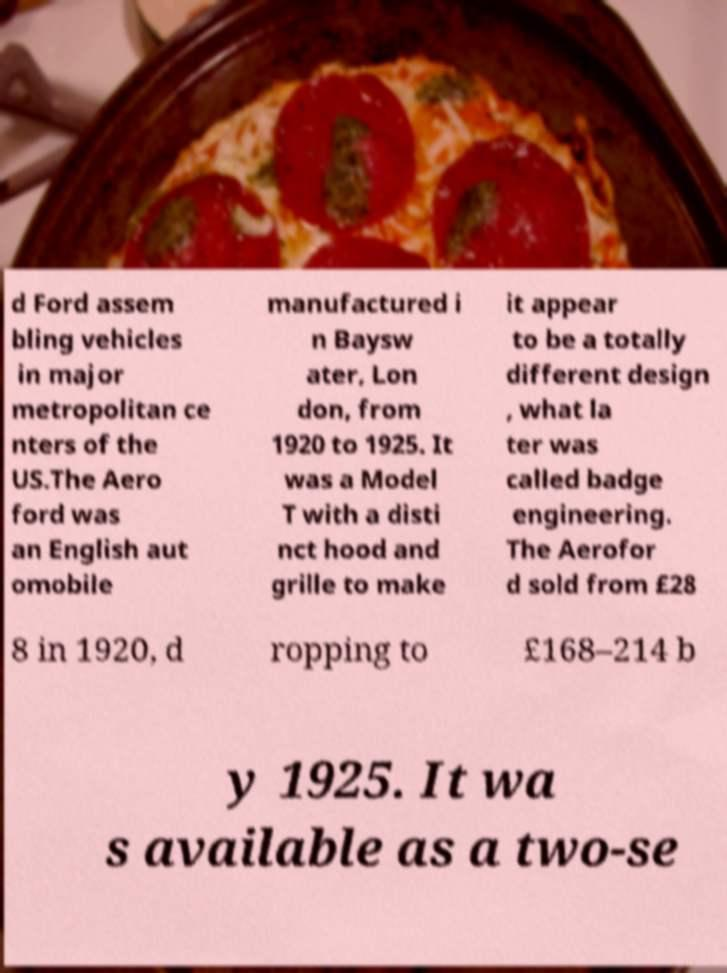Could you assist in decoding the text presented in this image and type it out clearly? d Ford assem bling vehicles in major metropolitan ce nters of the US.The Aero ford was an English aut omobile manufactured i n Baysw ater, Lon don, from 1920 to 1925. It was a Model T with a disti nct hood and grille to make it appear to be a totally different design , what la ter was called badge engineering. The Aerofor d sold from £28 8 in 1920, d ropping to £168–214 b y 1925. It wa s available as a two-se 